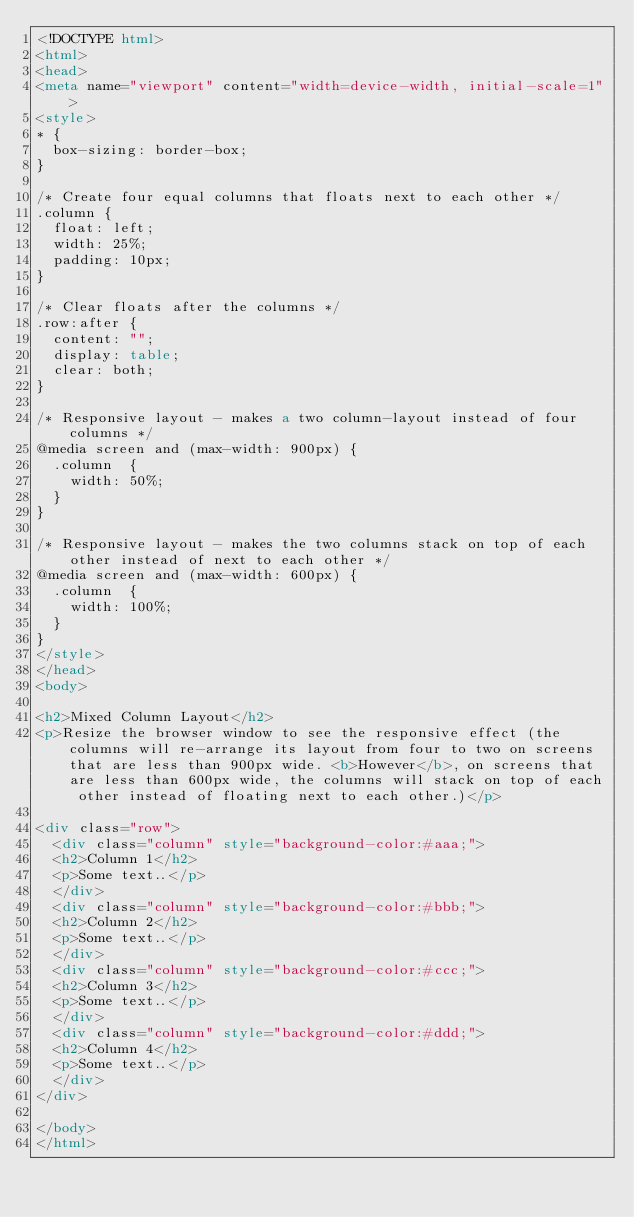Convert code to text. <code><loc_0><loc_0><loc_500><loc_500><_HTML_><!DOCTYPE html>
<html>
<head>
<meta name="viewport" content="width=device-width, initial-scale=1">
<style>
* {
  box-sizing: border-box;
}

/* Create four equal columns that floats next to each other */
.column {
  float: left;
  width: 25%;
  padding: 10px;
}

/* Clear floats after the columns */
.row:after {
  content: "";
  display: table;
  clear: both;
}

/* Responsive layout - makes a two column-layout instead of four columns */
@media screen and (max-width: 900px) {
  .column  {
    width: 50%;
  }
}

/* Responsive layout - makes the two columns stack on top of each other instead of next to each other */
@media screen and (max-width: 600px) {
  .column  {
    width: 100%;
  }
}
</style>
</head>
<body>

<h2>Mixed Column Layout</h2>
<p>Resize the browser window to see the responsive effect (the columns will re-arrange its layout from four to two on screens that are less than 900px wide. <b>However</b>, on screens that are less than 600px wide, the columns will stack on top of each other instead of floating next to each other.)</p>

<div class="row">
  <div class="column" style="background-color:#aaa;">
  <h2>Column 1</h2>
  <p>Some text..</p>
  </div>
  <div class="column" style="background-color:#bbb;">
  <h2>Column 2</h2>
  <p>Some text..</p>
  </div>
  <div class="column" style="background-color:#ccc;">
  <h2>Column 3</h2>
  <p>Some text..</p>
  </div>
  <div class="column" style="background-color:#ddd;">
  <h2>Column 4</h2>
  <p>Some text..</p>
  </div>
</div>

</body>
</html>
</code> 